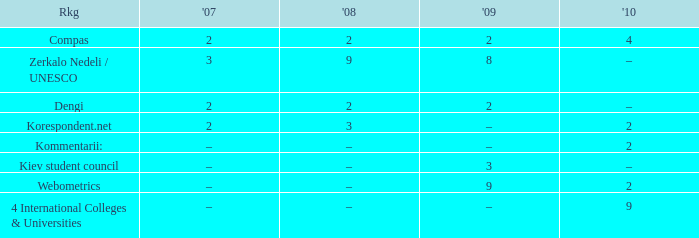What was the 2009 ranking for Webometrics? 9.0. 